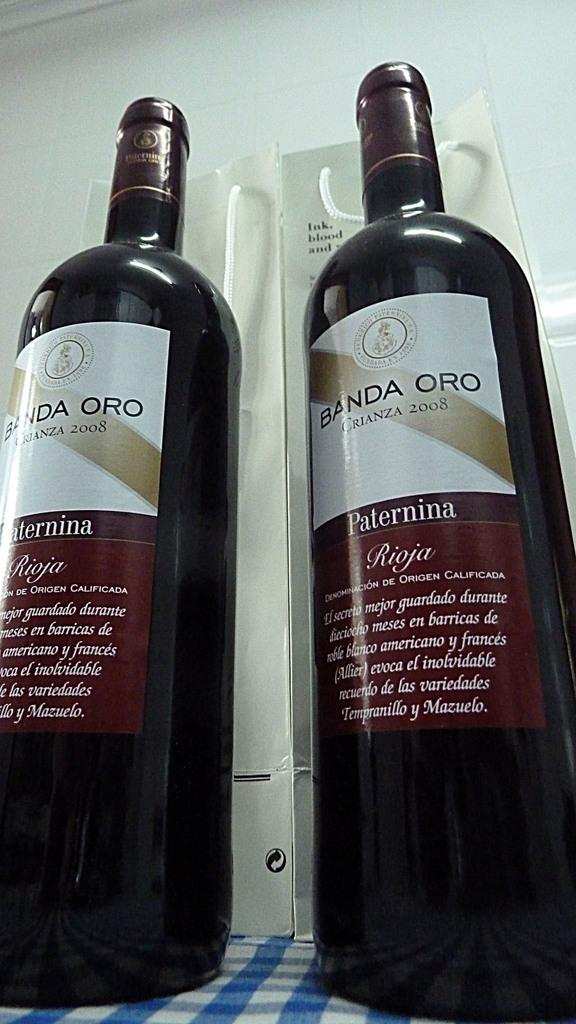<image>
Present a compact description of the photo's key features. Two bottles of wine named BANDA ORO Paternina. 